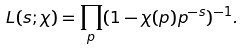<formula> <loc_0><loc_0><loc_500><loc_500>L ( s ; \chi ) = \prod _ { p } ( 1 - \chi ( p ) p ^ { - s } ) ^ { - 1 } .</formula> 